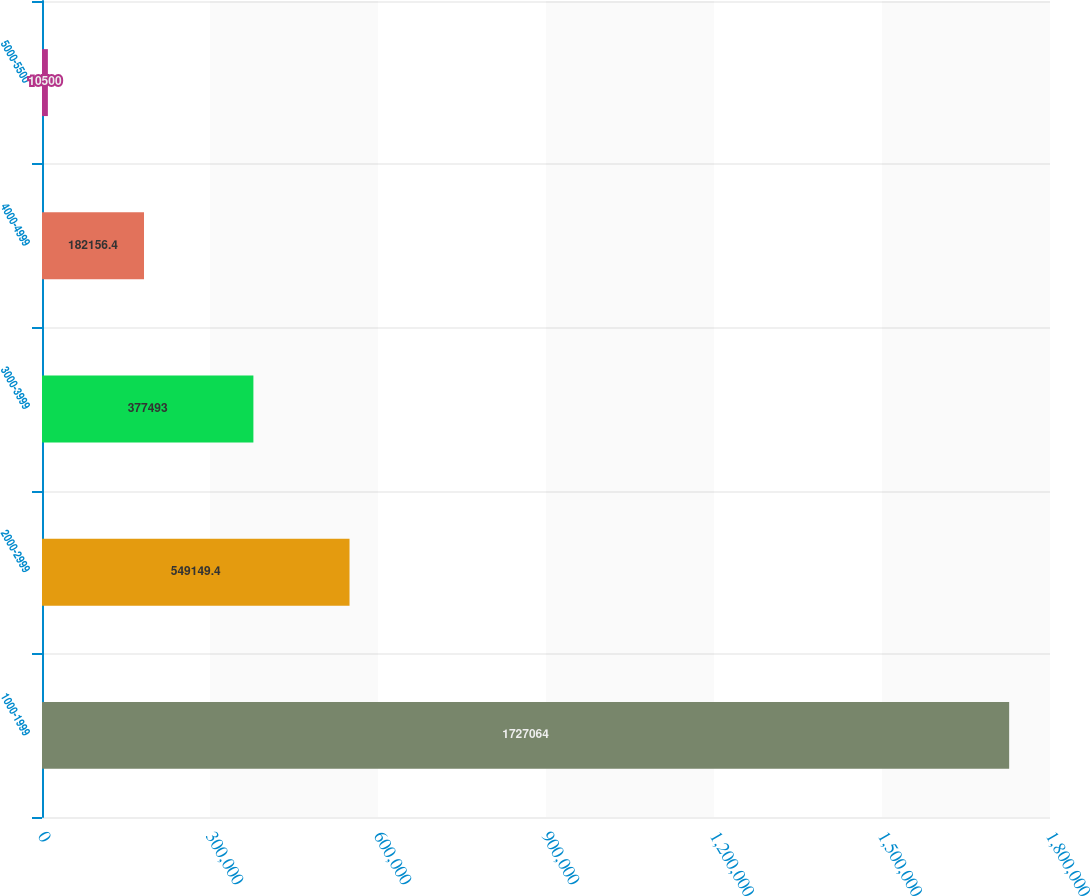<chart> <loc_0><loc_0><loc_500><loc_500><bar_chart><fcel>1000-1999<fcel>2000-2999<fcel>3000-3999<fcel>4000-4999<fcel>5000-5500<nl><fcel>1.72706e+06<fcel>549149<fcel>377493<fcel>182156<fcel>10500<nl></chart> 